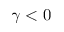<formula> <loc_0><loc_0><loc_500><loc_500>\gamma < 0</formula> 